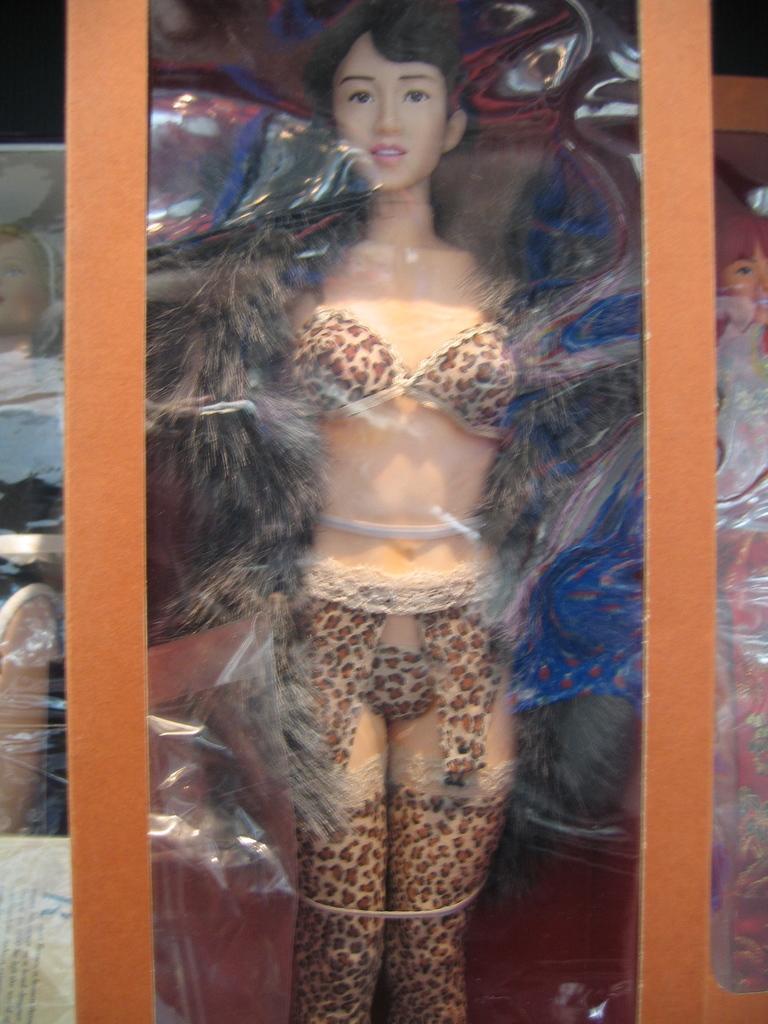In one or two sentences, can you explain what this image depicts? In this image there are depictions of women wearing different clothes are packed in a box and arranged in the rack. 